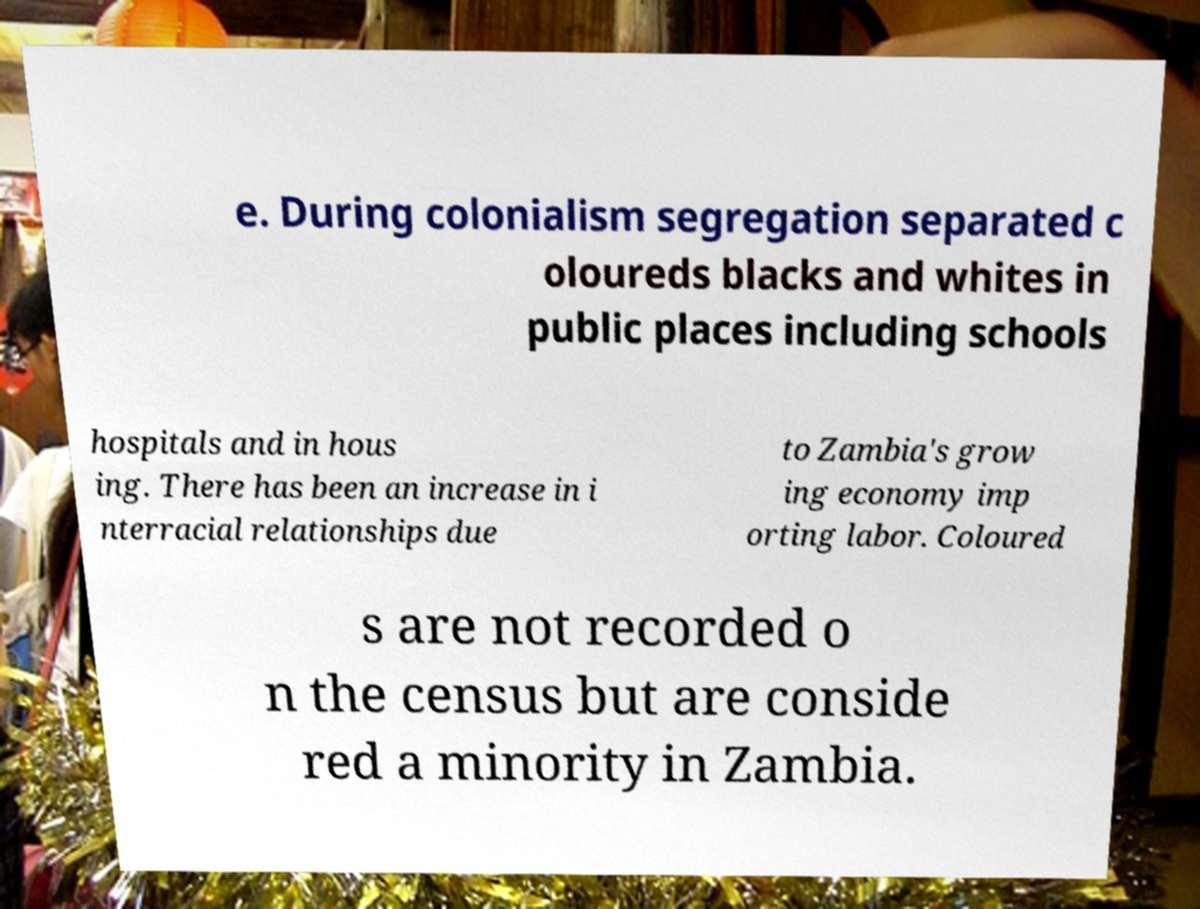Can you read and provide the text displayed in the image?This photo seems to have some interesting text. Can you extract and type it out for me? e. During colonialism segregation separated c oloureds blacks and whites in public places including schools hospitals and in hous ing. There has been an increase in i nterracial relationships due to Zambia's grow ing economy imp orting labor. Coloured s are not recorded o n the census but are conside red a minority in Zambia. 